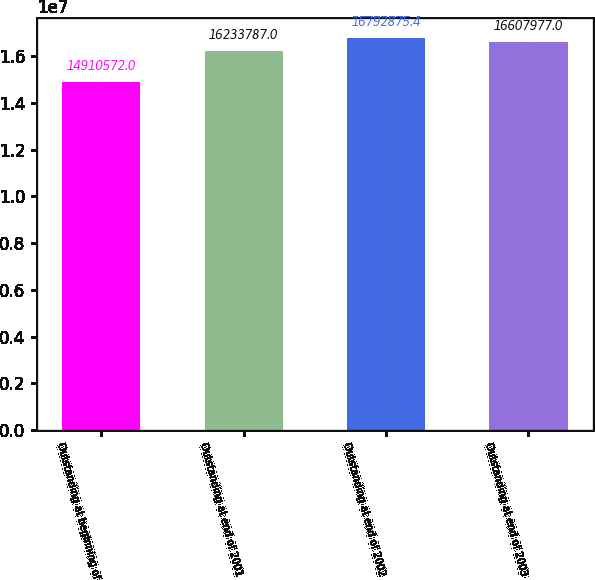Convert chart to OTSL. <chart><loc_0><loc_0><loc_500><loc_500><bar_chart><fcel>Outstanding at beginning of<fcel>Outstanding at end of 2001<fcel>Outstanding at end of 2002<fcel>Outstanding at end of 2003<nl><fcel>1.49106e+07<fcel>1.62338e+07<fcel>1.67929e+07<fcel>1.6608e+07<nl></chart> 